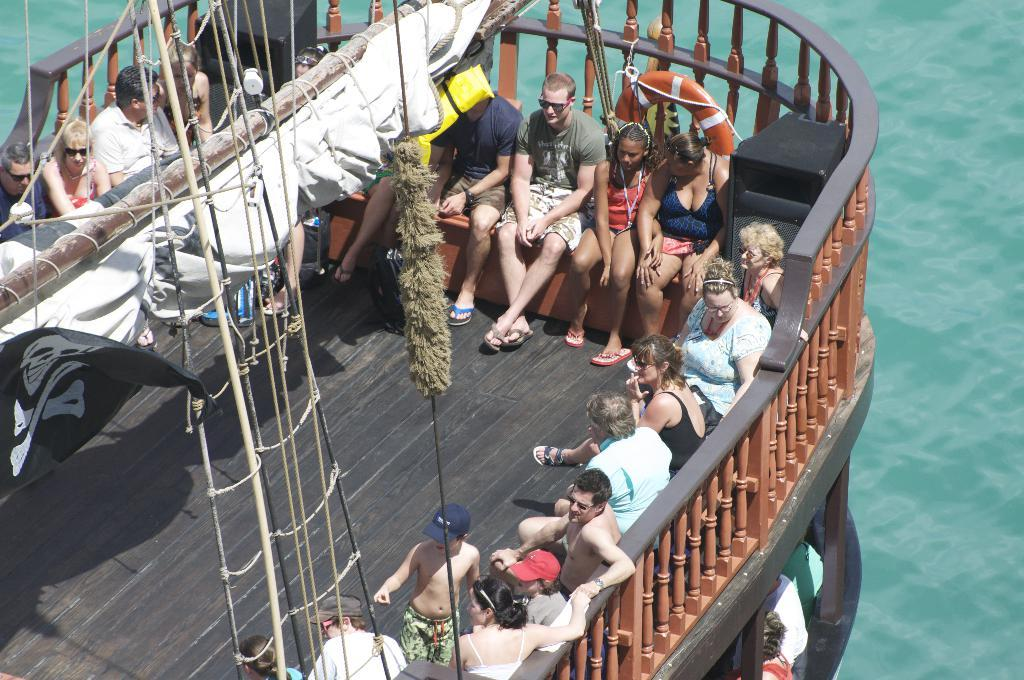What are the people in the boat doing? The persons are sitting in the boat. Is there anyone else in the boat besides the sitting persons? Yes, there is a kid standing in the boat. Where is the boat located? The boat is on the water. How many thumbs can be seen in the image? There is no information about thumbs in the image, so it cannot be determined. 